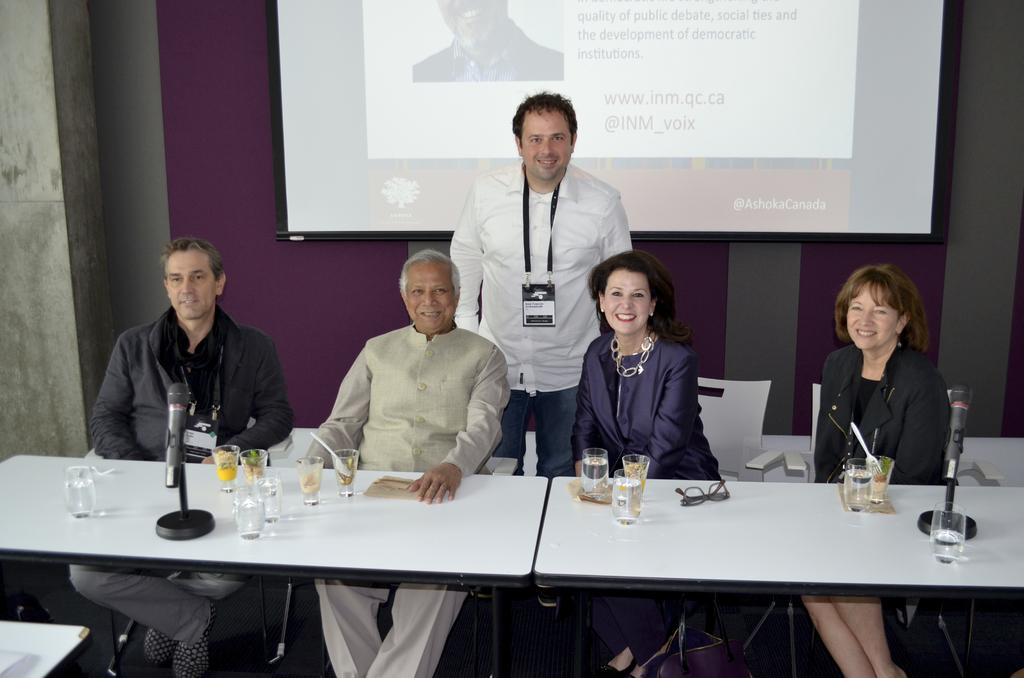How many people are sitting in the image? There are four persons sitting on chairs in the image. Is there anyone standing in the image? Yes, there is a person standing in the image. What items can be seen on the table? Glasses, specs, and microphones with stands are present on the table. What is visible in the background of the image? There is a screen and a wall in the background. How many chickens are present in the image? There are no chickens present in the image. What is the digestive process of the person standing in the image? The image does not provide information about the person's digestive process. 